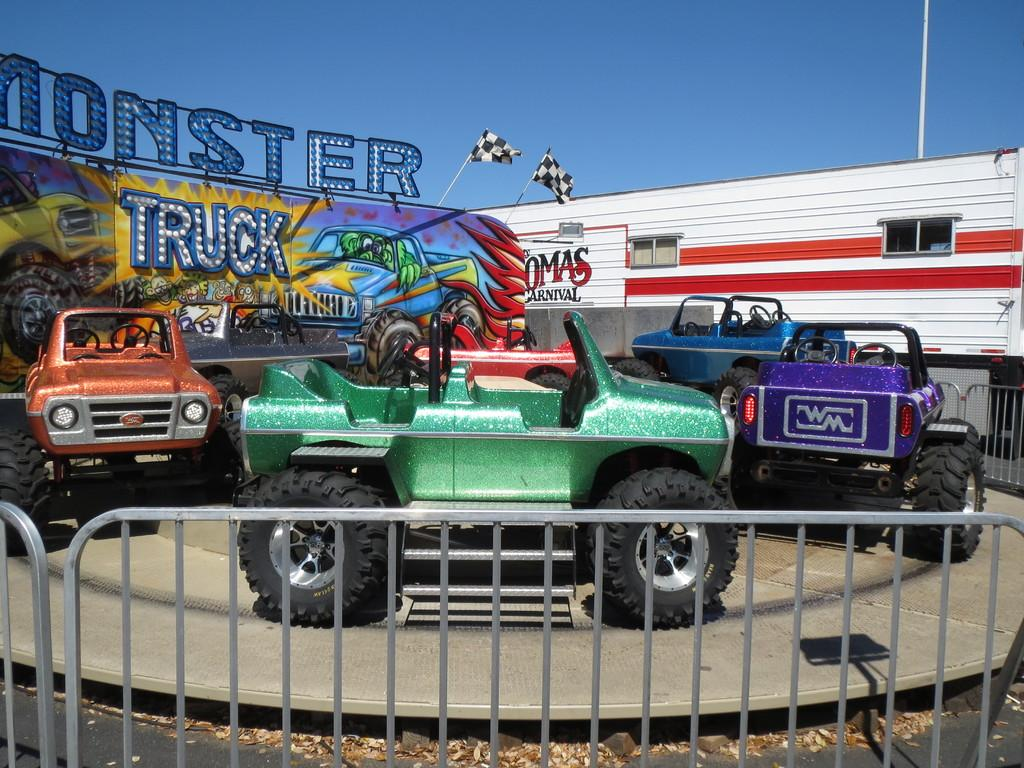What types of objects can be seen in the image? There are vehicles, barriers, flags with poles, and boards in the image. What might the barriers be used for? The barriers might be used to control traffic or separate areas in the image. What is visible in the background of the image? The sky is visible in the background of the image. What type of bird can be seen perched on the flagpole in the image? There are no birds present in the image, and therefore no bird can be seen perched on the flagpole. What material is the flagpole made of in the image? The provided facts do not mention the material of the flagpole, so it cannot be determined from the image. 